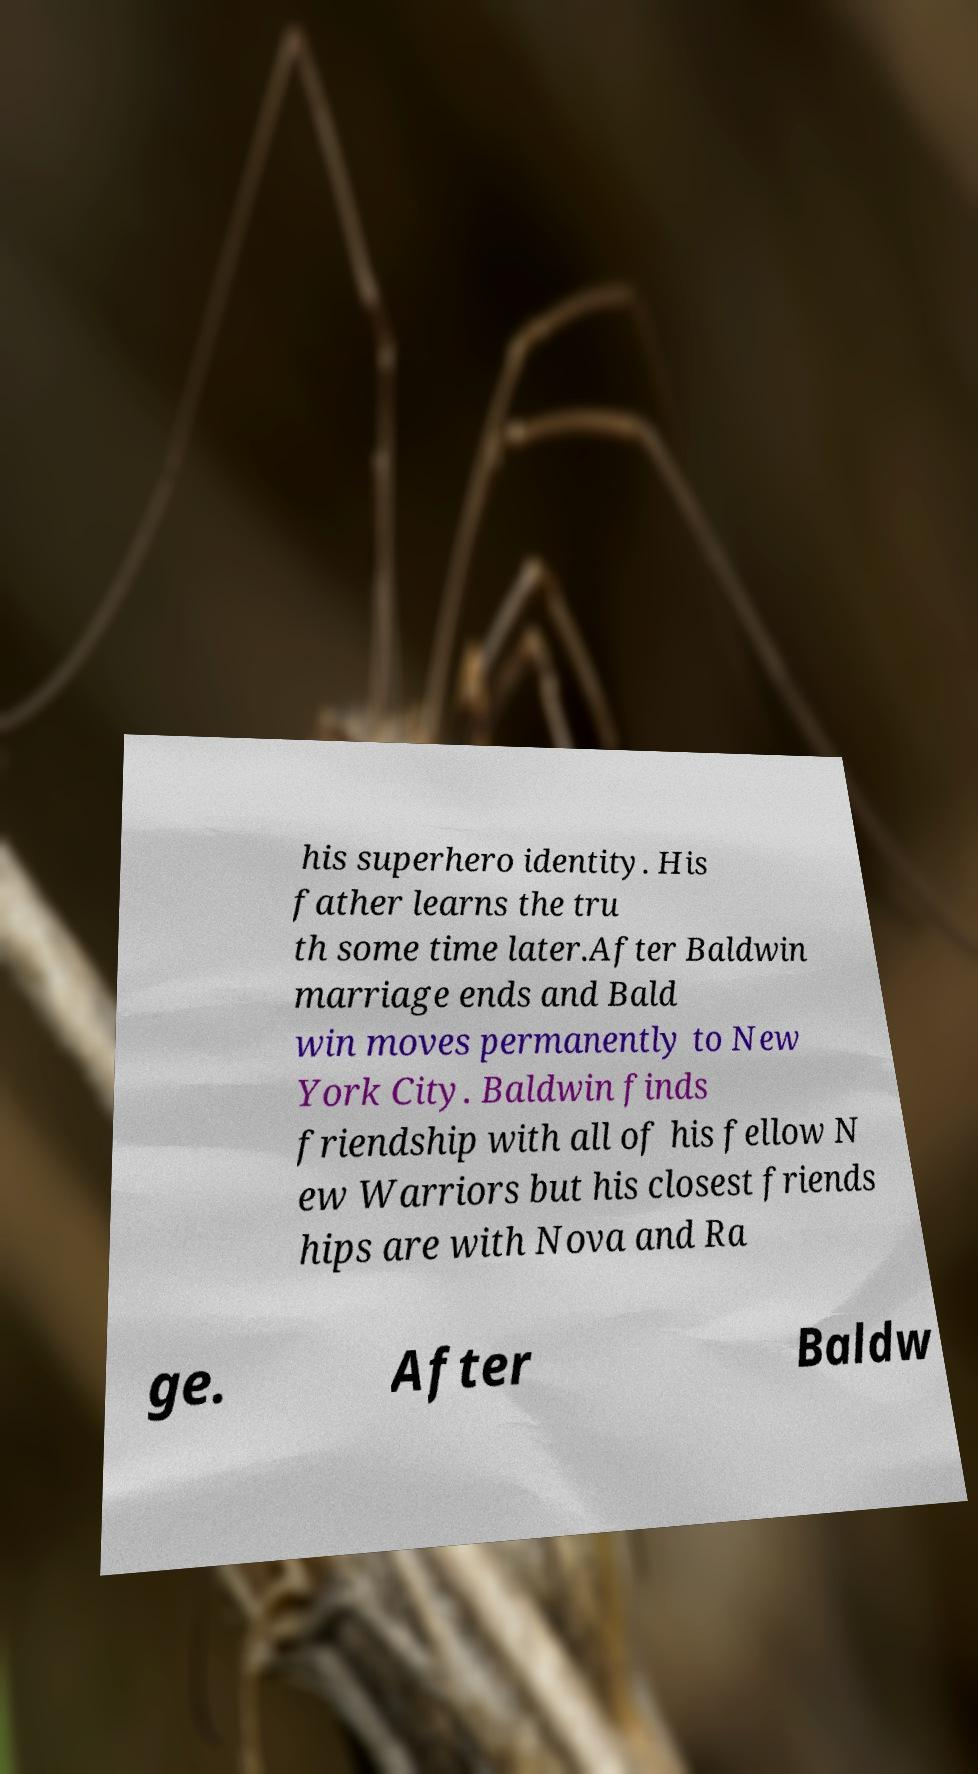For documentation purposes, I need the text within this image transcribed. Could you provide that? his superhero identity. His father learns the tru th some time later.After Baldwin marriage ends and Bald win moves permanently to New York City. Baldwin finds friendship with all of his fellow N ew Warriors but his closest friends hips are with Nova and Ra ge. After Baldw 